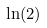Convert formula to latex. <formula><loc_0><loc_0><loc_500><loc_500>\ln ( 2 )</formula> 